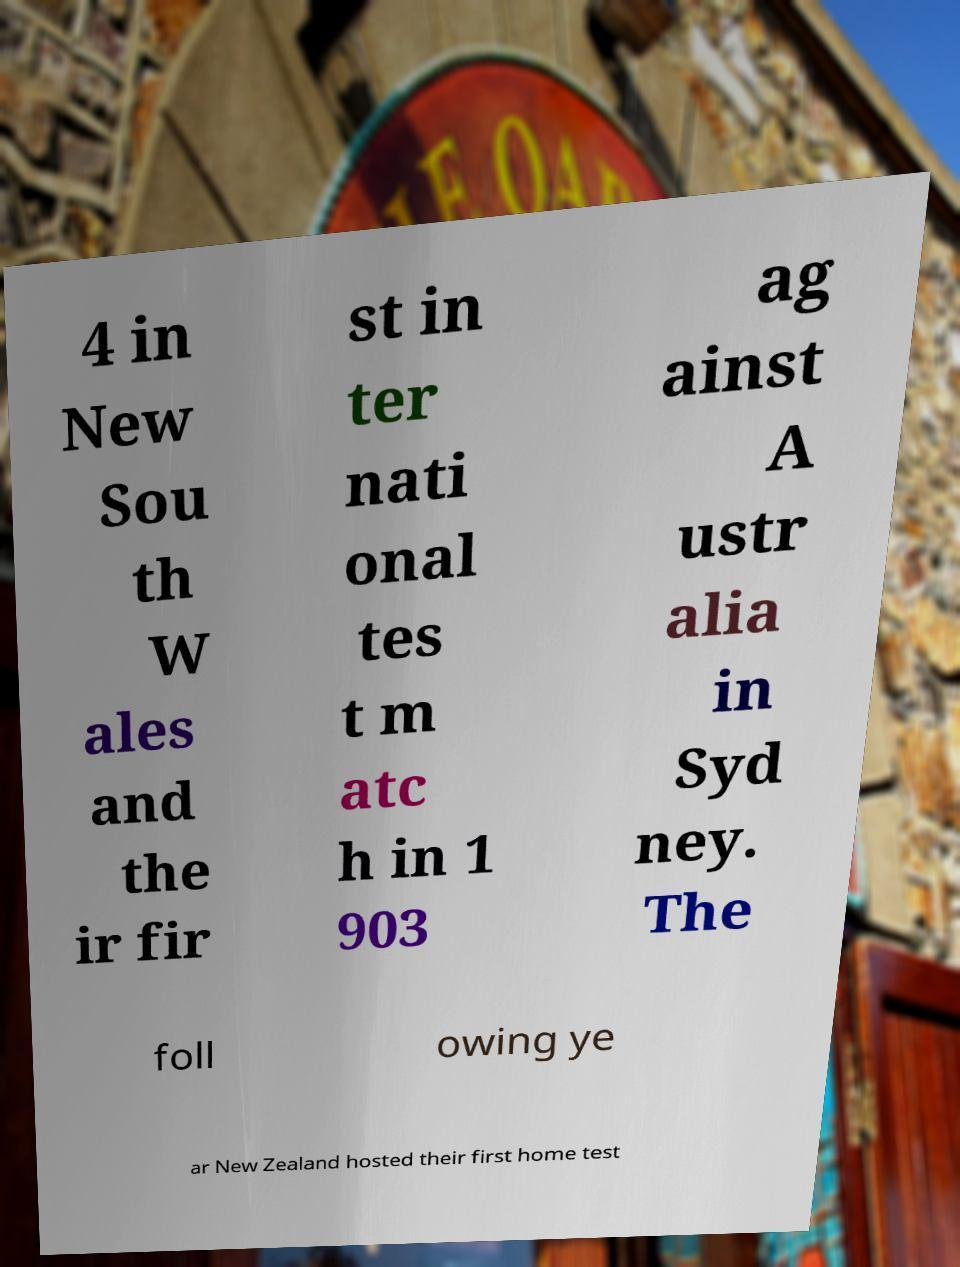For documentation purposes, I need the text within this image transcribed. Could you provide that? 4 in New Sou th W ales and the ir fir st in ter nati onal tes t m atc h in 1 903 ag ainst A ustr alia in Syd ney. The foll owing ye ar New Zealand hosted their first home test 